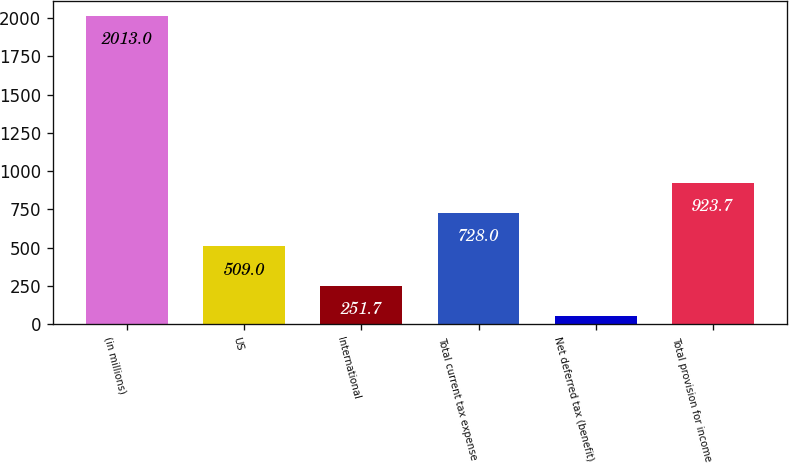Convert chart to OTSL. <chart><loc_0><loc_0><loc_500><loc_500><bar_chart><fcel>(in millions)<fcel>US<fcel>International<fcel>Total current tax expense<fcel>Net deferred tax (benefit)<fcel>Total provision for income<nl><fcel>2013<fcel>509<fcel>251.7<fcel>728<fcel>56<fcel>923.7<nl></chart> 